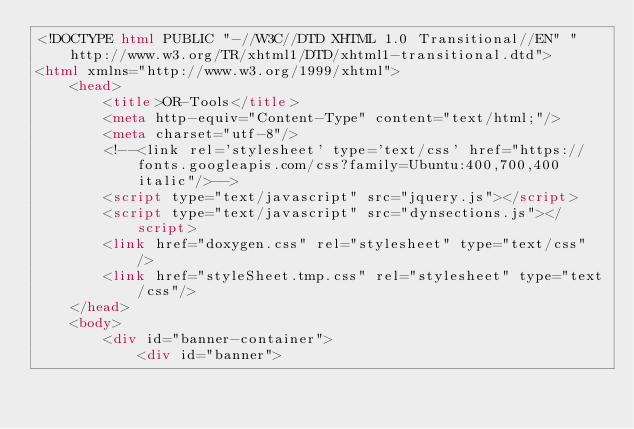<code> <loc_0><loc_0><loc_500><loc_500><_HTML_><!DOCTYPE html PUBLIC "-//W3C//DTD XHTML 1.0 Transitional//EN" "http://www.w3.org/TR/xhtml1/DTD/xhtml1-transitional.dtd">
<html xmlns="http://www.w3.org/1999/xhtml">
    <head>
        <title>OR-Tools</title>
        <meta http-equiv="Content-Type" content="text/html;"/>
        <meta charset="utf-8"/>
        <!--<link rel='stylesheet' type='text/css' href="https://fonts.googleapis.com/css?family=Ubuntu:400,700,400italic"/>-->
        <script type="text/javascript" src="jquery.js"></script>
        <script type="text/javascript" src="dynsections.js"></script>
        <link href="doxygen.css" rel="stylesheet" type="text/css" />
        <link href="styleSheet.tmp.css" rel="stylesheet" type="text/css"/>
    </head>
    <body>
        <div id="banner-container">
            <div id="banner"></code> 